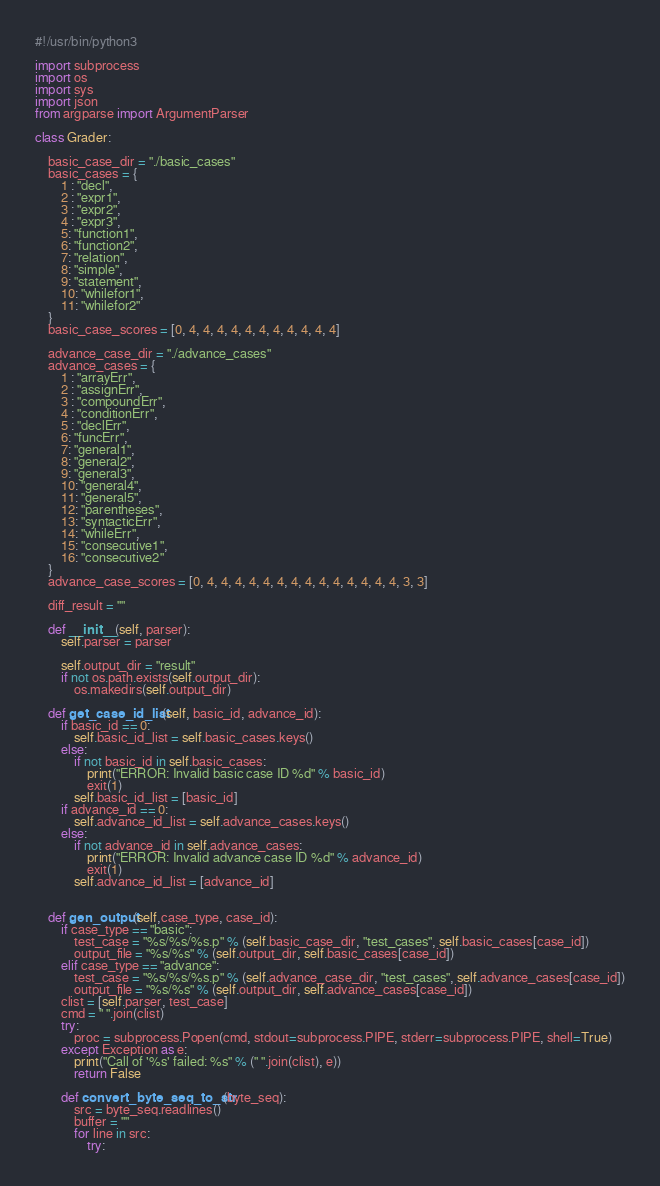<code> <loc_0><loc_0><loc_500><loc_500><_Python_>#!/usr/bin/python3

import subprocess
import os
import sys
import json
from argparse import ArgumentParser

class Grader:

    basic_case_dir = "./basic_cases"
    basic_cases = {
        1 : "decl",
        2 : "expr1",
        3 : "expr2",
        4 : "expr3",
        5: "function1",
        6: "function2",
        7: "relation",
        8: "simple",
        9: "statement",
        10: "whilefor1",
        11: "whilefor2"
    }
    basic_case_scores = [0, 4, 4, 4, 4, 4, 4, 4, 4, 4, 4, 4]

    advance_case_dir = "./advance_cases"
    advance_cases = {
        1 : "arrayErr",
        2 : "assignErr",
        3 : "compoundErr",
        4 : "conditionErr",
        5 : "declErr",
        6: "funcErr",
        7: "general1",
        8: "general2",
        9: "general3",
        10: "general4",
        11: "general5",
        12: "parentheses",
        13: "syntacticErr",
        14: "whileErr",
        15: "consecutive1",
        16: "consecutive2"
    }
    advance_case_scores = [0, 4, 4, 4, 4, 4, 4, 4, 4, 4, 4, 4, 4, 4, 4, 3, 3]

    diff_result = ""

    def __init__(self, parser):
        self.parser = parser

        self.output_dir = "result"
        if not os.path.exists(self.output_dir):
            os.makedirs(self.output_dir)

    def get_case_id_list(self, basic_id, advance_id):
        if basic_id == 0:
            self.basic_id_list = self.basic_cases.keys()
        else:
            if not basic_id in self.basic_cases:
                print("ERROR: Invalid basic case ID %d" % basic_id)
                exit(1)
            self.basic_id_list = [basic_id]
        if advance_id == 0:
            self.advance_id_list = self.advance_cases.keys()
        else:
            if not advance_id in self.advance_cases:
                print("ERROR: Invalid advance case ID %d" % advance_id)
                exit(1)
            self.advance_id_list = [advance_id]


    def gen_output(self,case_type, case_id):
        if case_type == "basic":
            test_case = "%s/%s/%s.p" % (self.basic_case_dir, "test_cases", self.basic_cases[case_id])
            output_file = "%s/%s" % (self.output_dir, self.basic_cases[case_id])
        elif case_type == "advance":
            test_case = "%s/%s/%s.p" % (self.advance_case_dir, "test_cases", self.advance_cases[case_id])
            output_file = "%s/%s" % (self.output_dir, self.advance_cases[case_id])
        clist = [self.parser, test_case]
        cmd = " ".join(clist)
        try:
            proc = subprocess.Popen(cmd, stdout=subprocess.PIPE, stderr=subprocess.PIPE, shell=True)
        except Exception as e:
            print("Call of '%s' failed: %s" % (" ".join(clist), e))
            return False

        def convert_byte_seq_to_str(byte_seq):
            src = byte_seq.readlines()
            buffer = ""
            for line in src:
                try:</code> 